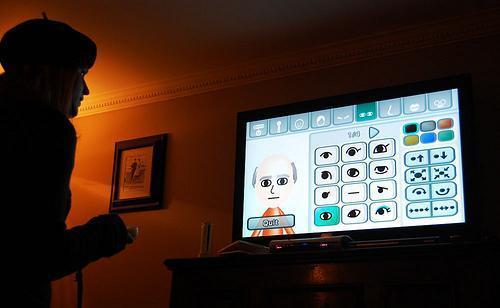How many men?
Give a very brief answer. 1. How many tvs are in the photo?
Give a very brief answer. 1. 